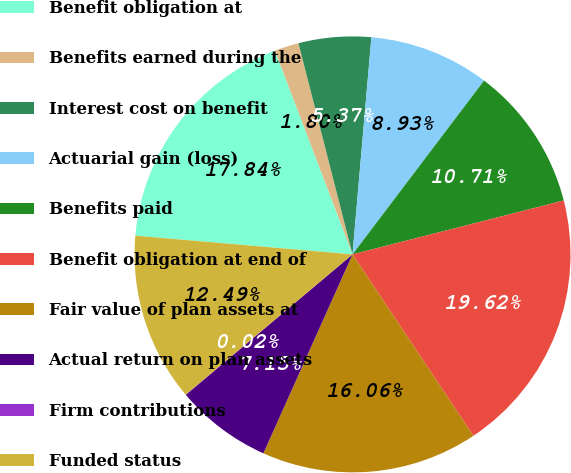Convert chart to OTSL. <chart><loc_0><loc_0><loc_500><loc_500><pie_chart><fcel>Benefit obligation at<fcel>Benefits earned during the<fcel>Interest cost on benefit<fcel>Actuarial gain (loss)<fcel>Benefits paid<fcel>Benefit obligation at end of<fcel>Fair value of plan assets at<fcel>Actual return on plan assets<fcel>Firm contributions<fcel>Funded status<nl><fcel>17.84%<fcel>1.8%<fcel>5.37%<fcel>8.93%<fcel>10.71%<fcel>19.62%<fcel>16.06%<fcel>7.15%<fcel>0.02%<fcel>12.49%<nl></chart> 